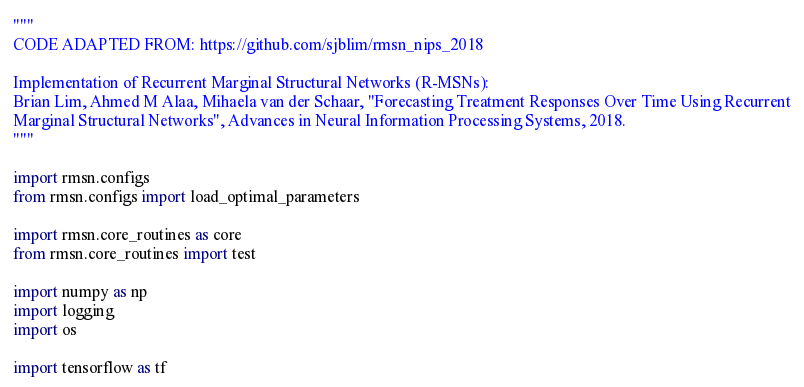<code> <loc_0><loc_0><loc_500><loc_500><_Python_>"""
CODE ADAPTED FROM: https://github.com/sjblim/rmsn_nips_2018

Implementation of Recurrent Marginal Structural Networks (R-MSNs):
Brian Lim, Ahmed M Alaa, Mihaela van der Schaar, "Forecasting Treatment Responses Over Time Using Recurrent
Marginal Structural Networks", Advances in Neural Information Processing Systems, 2018.
"""

import rmsn.configs
from rmsn.configs import load_optimal_parameters

import rmsn.core_routines as core
from rmsn.core_routines import test

import numpy as np
import logging
import os

import tensorflow as tf</code> 